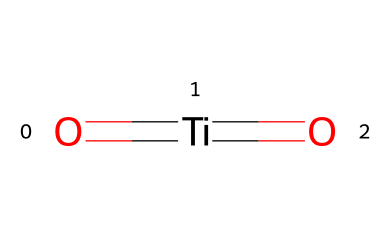What is the name of this chemical? The SMILES representation indicates the presence of titanium (Ti) and oxygen (O) atoms, and it is a well-known photocatalyst commonly used in self-cleaning surfaces. Therefore, the name of the chemical is derived from its components.
Answer: titanium dioxide How many oxygen atoms are present in the structure? The SMILES representation shows two oxygen atoms (O) surrounding the titanium center, which indicates their presence in the chemical structure.
Answer: 2 What type of bonding is present between titanium and oxygen? The SMILES notation includes a double bond indication (the equal sign), which shows that there are double bonds between the titanium atom and each of the oxygen atoms.
Answer: double bond What role does titanium dioxide play in photocatalytic reactions? Titanium dioxide serves as a photocatalyst in various reactions, especially in the presence of light. This property is tied to its ability to absorb UV light and generate reactive species.
Answer: photocatalyst What is the oxidation state of titanium in this compound? To determine the oxidation state, we consider that oxygen typically has an oxidation state of -2 and there are two oxygen atoms providing a total of -4. To balance the compound as neutral, titanium must be +4.
Answer: +4 Is titanium dioxide effective under visible light? Titanium dioxide primarily absorbs UV light, so its photocatalytic effectiveness is significantly less under visible light wavelengths.
Answer: no 